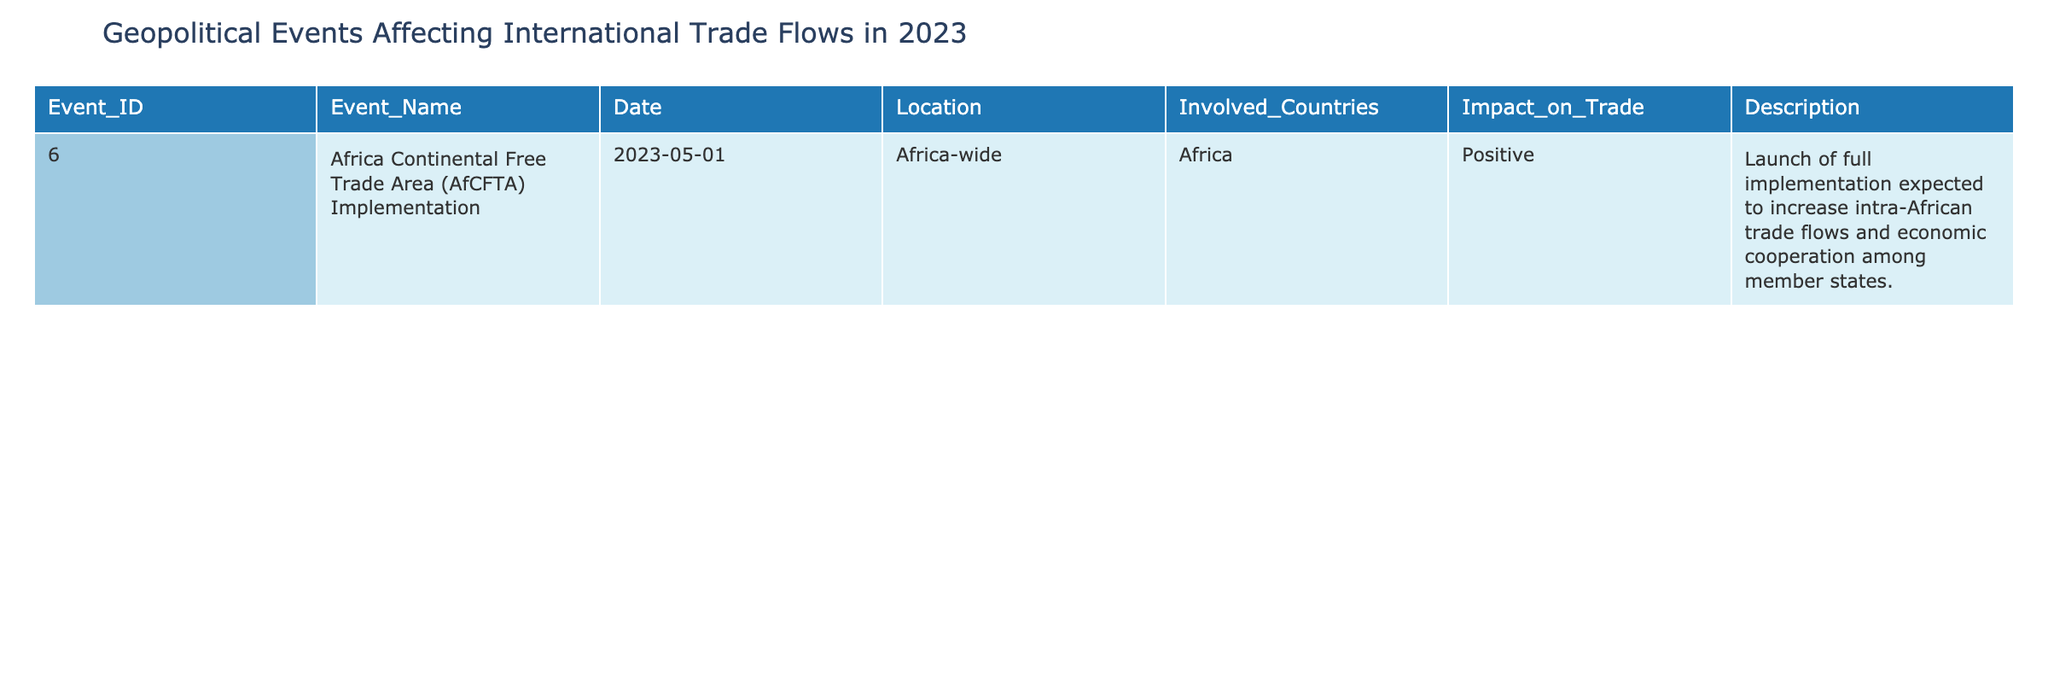What is the name of the event related to African trade implemented in 2023? The table specifies that the event is called "Africa Continental Free Trade Area (AfCFTA) Implementation."
Answer: Africa Continental Free Trade Area (AfCFTA) Implementation On what date was the AfCFTA event launched? According to the table, the implementation of AfCFTA was launched on May 1, 2023.
Answer: May 1, 2023 How many countries are involved in the AfCFTA? The data indicates that the event involves Africa as a whole, implying participation from multiple countries across the continent, classified as "Africa."
Answer: Africa Does the implementation of AfCFTA have a positive impact on trade? Yes, the description in the table explicitly states that the launch is expected to increase intra-African trade flows and foster economic cooperation among member states, indicating a positive impact.
Answer: Yes What is the key outcome expected from the AfCFTA implementation? The table indicates that the expected key outcome of the AfCFTA implementation is an increase in intra-African trade flows and enhanced economic cooperation among member states.
Answer: Increase in intra-African trade flows Considering only the data provided, how many events are described as affecting international trade flows in 2023? There is only one event in the provided table related to international trade flows, which is the AfCFTA implementation. The count of events is derived from the number of rows in the table.
Answer: 1 If the AfCFTA is fully implemented, what type of economic relationship does it aim to enhance? The description in the table notes that the AfCFTA aims to enhance economic cooperation among member states, indicating the relationship it seeks to strengthen.
Answer: Economic cooperation What geographic area does the AfCFTA implementation pertain to? The table specifies that the location of the event is Africa-wide, covering the entire continent and its associated member states.
Answer: Africa-wide How might the implementation of the AfCFTA affect trade dynamics within Africa? The description suggests that the AfCFTA implementation is expected to boost trade flows, indicating a dynamic shift towards increased intra-African trade relationships.
Answer: Boost trade flows 